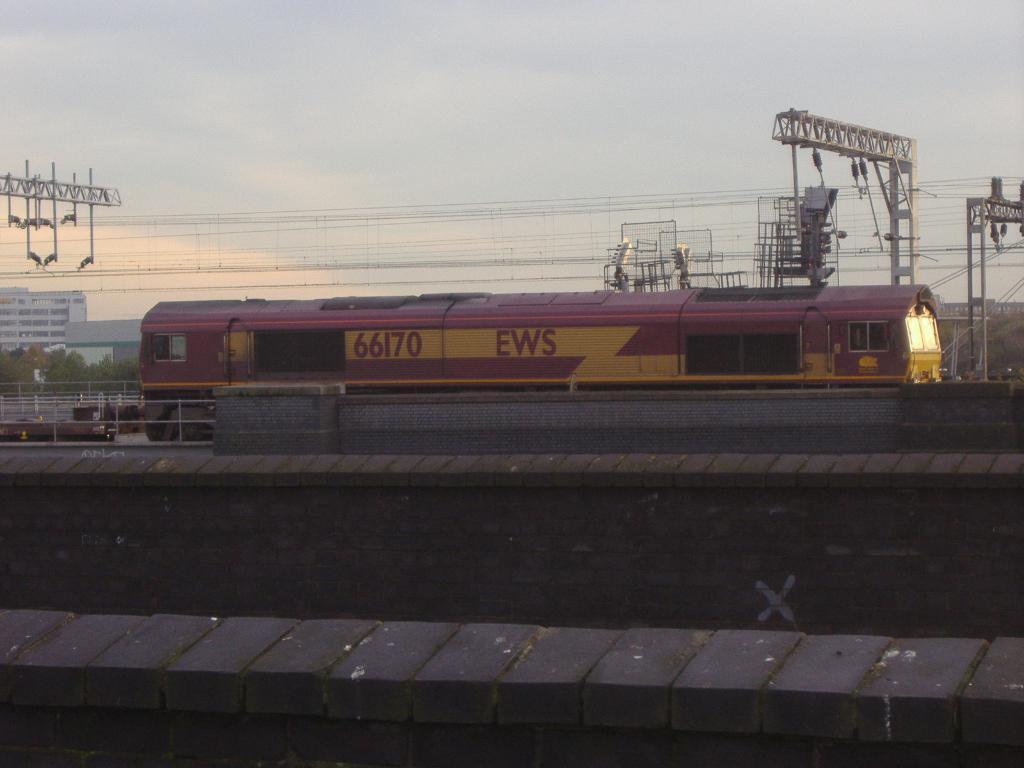In one or two sentences, can you explain what this image depicts? In this picture we can see a train and railings in the middle, there are poles and wires on the right side, in the background we can see trees and buildings, there is the sky at the top of the picture. 